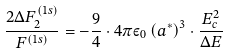Convert formula to latex. <formula><loc_0><loc_0><loc_500><loc_500>\frac { { 2 \Delta F _ { 2 } ^ { ( 1 s ) } } } { { F ^ { ( 1 s ) } } } = - \frac { 9 } { 4 } \cdot 4 \pi \varepsilon _ { 0 } \left ( { a ^ { * } } \right ) ^ { 3 } \cdot \frac { E _ { c } ^ { 2 } } { \Delta E }</formula> 